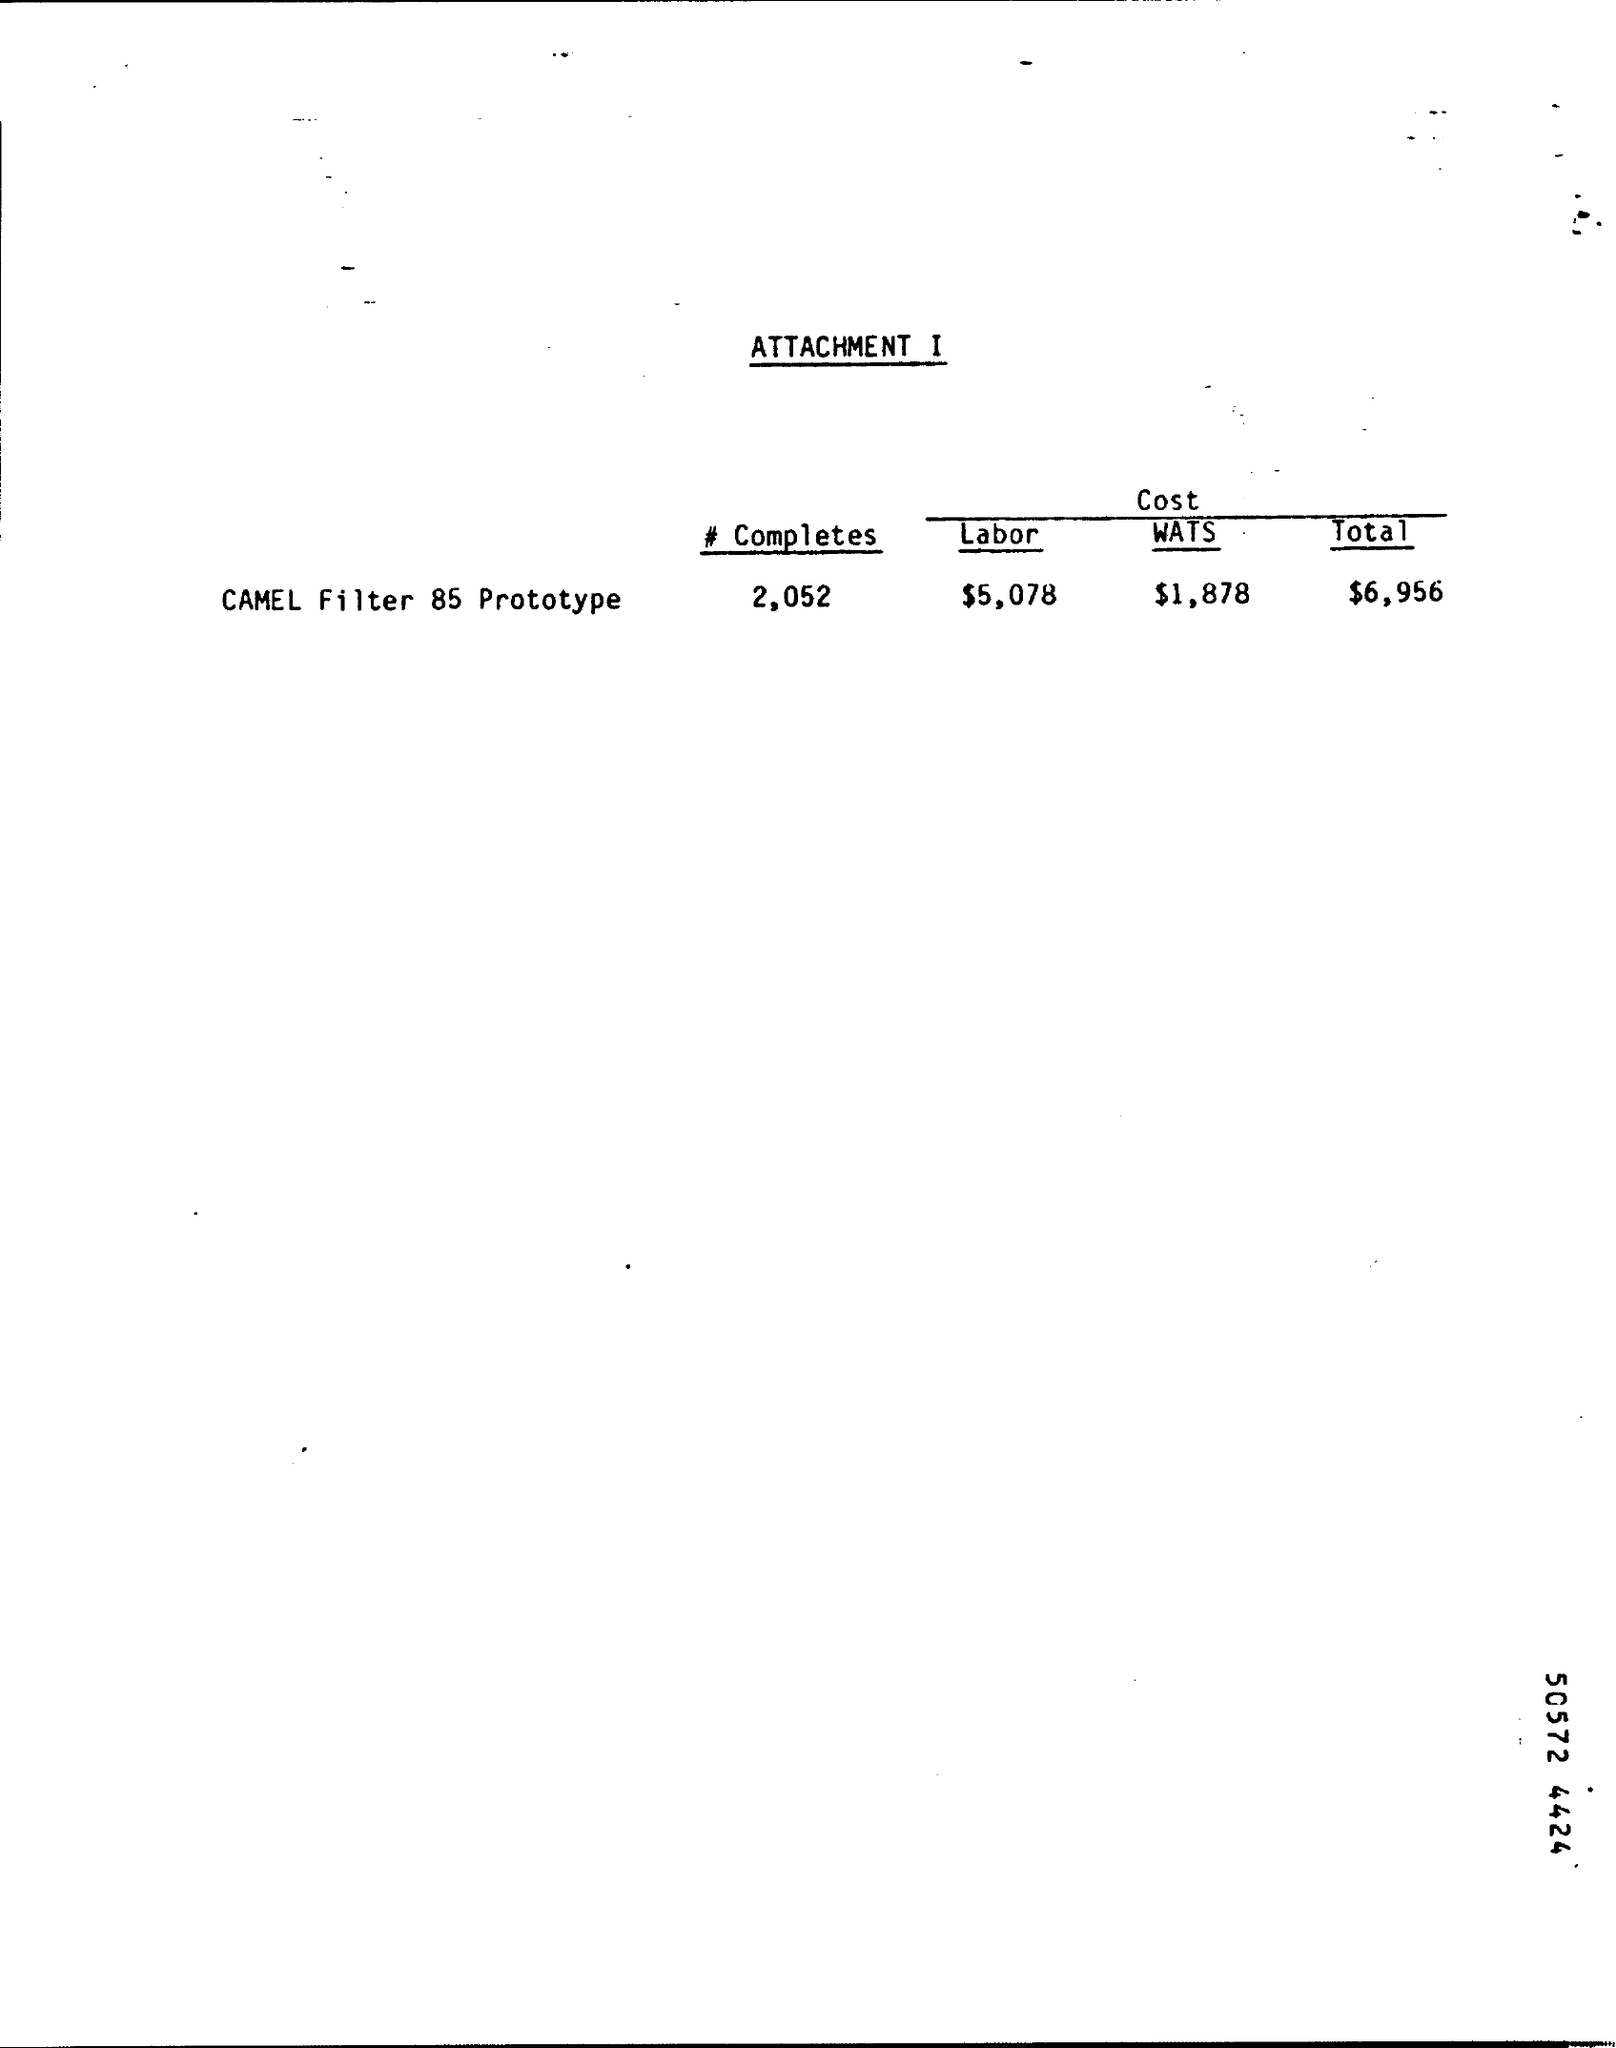Give some essential details in this illustration. The total cost for the Camel Filter 85 prototype is $6,956. The labor cost, as stated in the attachment, is $5,078. The cost of a camel filter prototype 85 is $1,878. 